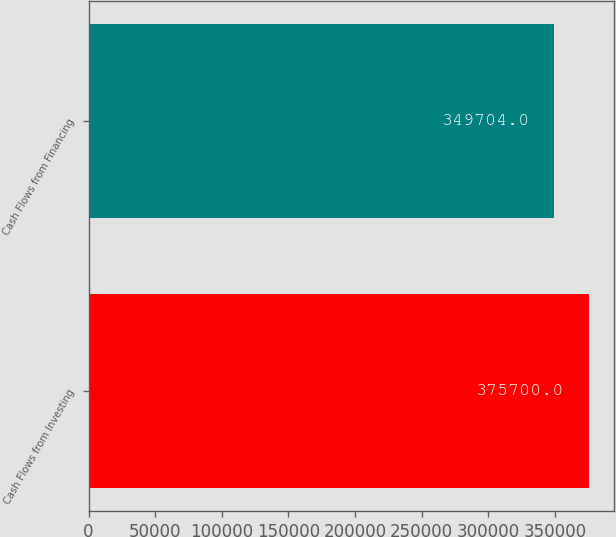Convert chart. <chart><loc_0><loc_0><loc_500><loc_500><bar_chart><fcel>Cash Flows from Investing<fcel>Cash Flows from Financing<nl><fcel>375700<fcel>349704<nl></chart> 